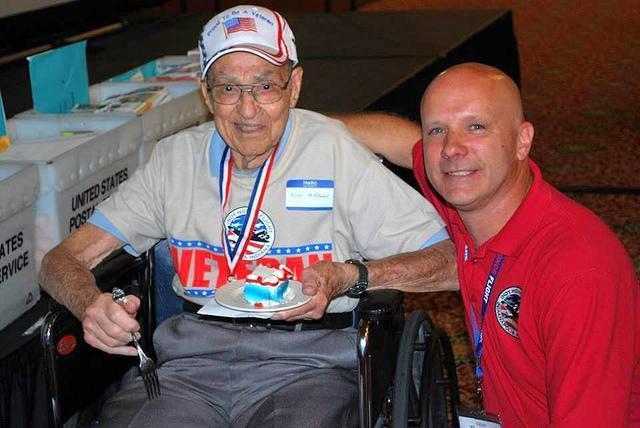How many men are shown?
Give a very brief answer. 2. How many people are wearing hats?
Give a very brief answer. 1. How many faces can be seen?
Give a very brief answer. 2. How many people can you see?
Give a very brief answer. 2. 